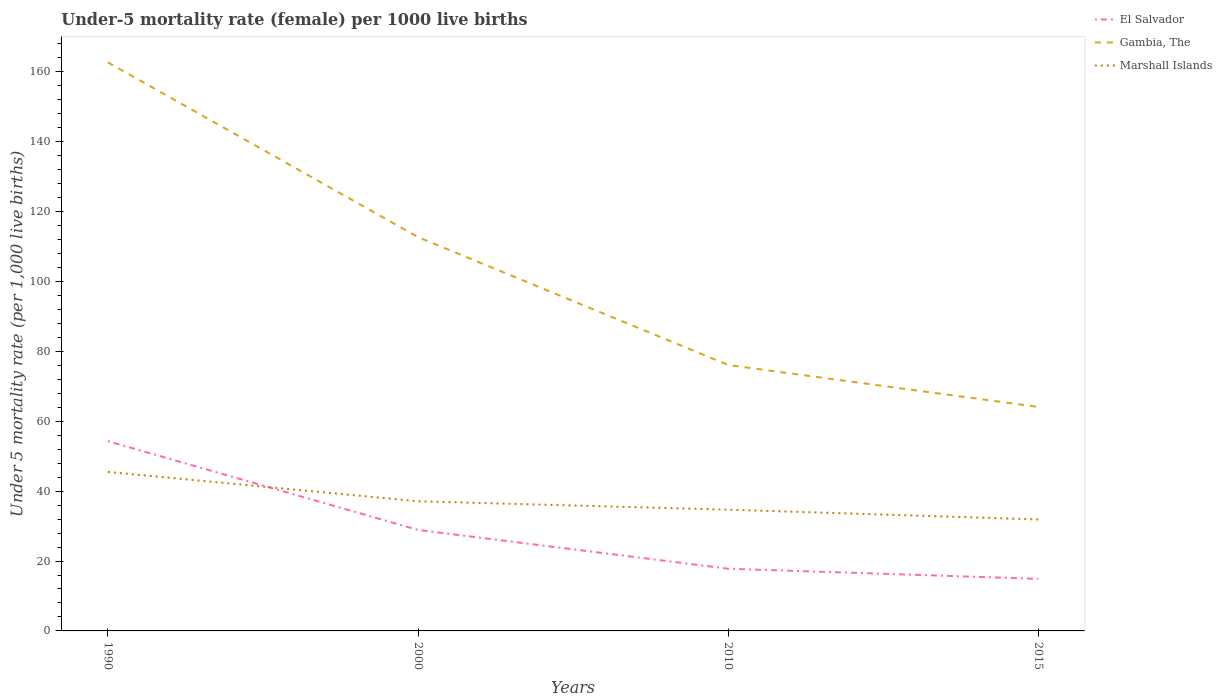How many different coloured lines are there?
Provide a short and direct response. 3. In which year was the under-five mortality rate in Gambia, The maximum?
Offer a very short reply. 2015. What is the total under-five mortality rate in Marshall Islands in the graph?
Give a very brief answer. 2.4. What is the difference between the highest and the second highest under-five mortality rate in Marshall Islands?
Your response must be concise. 13.6. What is the difference between the highest and the lowest under-five mortality rate in Gambia, The?
Offer a very short reply. 2. Are the values on the major ticks of Y-axis written in scientific E-notation?
Your response must be concise. No. Does the graph contain grids?
Provide a short and direct response. No. Where does the legend appear in the graph?
Offer a very short reply. Top right. What is the title of the graph?
Provide a short and direct response. Under-5 mortality rate (female) per 1000 live births. What is the label or title of the X-axis?
Offer a very short reply. Years. What is the label or title of the Y-axis?
Your response must be concise. Under 5 mortality rate (per 1,0 live births). What is the Under 5 mortality rate (per 1,000 live births) of El Salvador in 1990?
Give a very brief answer. 54.3. What is the Under 5 mortality rate (per 1,000 live births) of Gambia, The in 1990?
Offer a terse response. 162.7. What is the Under 5 mortality rate (per 1,000 live births) in Marshall Islands in 1990?
Make the answer very short. 45.5. What is the Under 5 mortality rate (per 1,000 live births) of El Salvador in 2000?
Ensure brevity in your answer.  28.9. What is the Under 5 mortality rate (per 1,000 live births) of Gambia, The in 2000?
Give a very brief answer. 112.7. What is the Under 5 mortality rate (per 1,000 live births) in Marshall Islands in 2000?
Make the answer very short. 37.1. What is the Under 5 mortality rate (per 1,000 live births) in Gambia, The in 2010?
Your response must be concise. 76.1. What is the Under 5 mortality rate (per 1,000 live births) of Marshall Islands in 2010?
Make the answer very short. 34.7. What is the Under 5 mortality rate (per 1,000 live births) of Gambia, The in 2015?
Offer a terse response. 64.1. What is the Under 5 mortality rate (per 1,000 live births) of Marshall Islands in 2015?
Keep it short and to the point. 31.9. Across all years, what is the maximum Under 5 mortality rate (per 1,000 live births) of El Salvador?
Give a very brief answer. 54.3. Across all years, what is the maximum Under 5 mortality rate (per 1,000 live births) in Gambia, The?
Keep it short and to the point. 162.7. Across all years, what is the maximum Under 5 mortality rate (per 1,000 live births) of Marshall Islands?
Provide a succinct answer. 45.5. Across all years, what is the minimum Under 5 mortality rate (per 1,000 live births) in El Salvador?
Your answer should be compact. 14.9. Across all years, what is the minimum Under 5 mortality rate (per 1,000 live births) of Gambia, The?
Your response must be concise. 64.1. Across all years, what is the minimum Under 5 mortality rate (per 1,000 live births) of Marshall Islands?
Your response must be concise. 31.9. What is the total Under 5 mortality rate (per 1,000 live births) in El Salvador in the graph?
Give a very brief answer. 115.9. What is the total Under 5 mortality rate (per 1,000 live births) in Gambia, The in the graph?
Offer a terse response. 415.6. What is the total Under 5 mortality rate (per 1,000 live births) of Marshall Islands in the graph?
Your answer should be compact. 149.2. What is the difference between the Under 5 mortality rate (per 1,000 live births) of El Salvador in 1990 and that in 2000?
Give a very brief answer. 25.4. What is the difference between the Under 5 mortality rate (per 1,000 live births) of Gambia, The in 1990 and that in 2000?
Ensure brevity in your answer.  50. What is the difference between the Under 5 mortality rate (per 1,000 live births) of El Salvador in 1990 and that in 2010?
Your answer should be very brief. 36.5. What is the difference between the Under 5 mortality rate (per 1,000 live births) in Gambia, The in 1990 and that in 2010?
Your answer should be very brief. 86.6. What is the difference between the Under 5 mortality rate (per 1,000 live births) of Marshall Islands in 1990 and that in 2010?
Ensure brevity in your answer.  10.8. What is the difference between the Under 5 mortality rate (per 1,000 live births) in El Salvador in 1990 and that in 2015?
Make the answer very short. 39.4. What is the difference between the Under 5 mortality rate (per 1,000 live births) of Gambia, The in 1990 and that in 2015?
Your response must be concise. 98.6. What is the difference between the Under 5 mortality rate (per 1,000 live births) in El Salvador in 2000 and that in 2010?
Your response must be concise. 11.1. What is the difference between the Under 5 mortality rate (per 1,000 live births) of Gambia, The in 2000 and that in 2010?
Keep it short and to the point. 36.6. What is the difference between the Under 5 mortality rate (per 1,000 live births) of El Salvador in 2000 and that in 2015?
Ensure brevity in your answer.  14. What is the difference between the Under 5 mortality rate (per 1,000 live births) in Gambia, The in 2000 and that in 2015?
Keep it short and to the point. 48.6. What is the difference between the Under 5 mortality rate (per 1,000 live births) of El Salvador in 2010 and that in 2015?
Provide a succinct answer. 2.9. What is the difference between the Under 5 mortality rate (per 1,000 live births) in El Salvador in 1990 and the Under 5 mortality rate (per 1,000 live births) in Gambia, The in 2000?
Offer a very short reply. -58.4. What is the difference between the Under 5 mortality rate (per 1,000 live births) of El Salvador in 1990 and the Under 5 mortality rate (per 1,000 live births) of Marshall Islands in 2000?
Offer a terse response. 17.2. What is the difference between the Under 5 mortality rate (per 1,000 live births) of Gambia, The in 1990 and the Under 5 mortality rate (per 1,000 live births) of Marshall Islands in 2000?
Offer a very short reply. 125.6. What is the difference between the Under 5 mortality rate (per 1,000 live births) of El Salvador in 1990 and the Under 5 mortality rate (per 1,000 live births) of Gambia, The in 2010?
Your answer should be compact. -21.8. What is the difference between the Under 5 mortality rate (per 1,000 live births) of El Salvador in 1990 and the Under 5 mortality rate (per 1,000 live births) of Marshall Islands in 2010?
Offer a terse response. 19.6. What is the difference between the Under 5 mortality rate (per 1,000 live births) in Gambia, The in 1990 and the Under 5 mortality rate (per 1,000 live births) in Marshall Islands in 2010?
Your answer should be very brief. 128. What is the difference between the Under 5 mortality rate (per 1,000 live births) in El Salvador in 1990 and the Under 5 mortality rate (per 1,000 live births) in Gambia, The in 2015?
Ensure brevity in your answer.  -9.8. What is the difference between the Under 5 mortality rate (per 1,000 live births) of El Salvador in 1990 and the Under 5 mortality rate (per 1,000 live births) of Marshall Islands in 2015?
Keep it short and to the point. 22.4. What is the difference between the Under 5 mortality rate (per 1,000 live births) in Gambia, The in 1990 and the Under 5 mortality rate (per 1,000 live births) in Marshall Islands in 2015?
Your answer should be very brief. 130.8. What is the difference between the Under 5 mortality rate (per 1,000 live births) of El Salvador in 2000 and the Under 5 mortality rate (per 1,000 live births) of Gambia, The in 2010?
Offer a very short reply. -47.2. What is the difference between the Under 5 mortality rate (per 1,000 live births) of Gambia, The in 2000 and the Under 5 mortality rate (per 1,000 live births) of Marshall Islands in 2010?
Provide a short and direct response. 78. What is the difference between the Under 5 mortality rate (per 1,000 live births) in El Salvador in 2000 and the Under 5 mortality rate (per 1,000 live births) in Gambia, The in 2015?
Offer a terse response. -35.2. What is the difference between the Under 5 mortality rate (per 1,000 live births) in Gambia, The in 2000 and the Under 5 mortality rate (per 1,000 live births) in Marshall Islands in 2015?
Keep it short and to the point. 80.8. What is the difference between the Under 5 mortality rate (per 1,000 live births) of El Salvador in 2010 and the Under 5 mortality rate (per 1,000 live births) of Gambia, The in 2015?
Give a very brief answer. -46.3. What is the difference between the Under 5 mortality rate (per 1,000 live births) of El Salvador in 2010 and the Under 5 mortality rate (per 1,000 live births) of Marshall Islands in 2015?
Your answer should be very brief. -14.1. What is the difference between the Under 5 mortality rate (per 1,000 live births) in Gambia, The in 2010 and the Under 5 mortality rate (per 1,000 live births) in Marshall Islands in 2015?
Provide a short and direct response. 44.2. What is the average Under 5 mortality rate (per 1,000 live births) of El Salvador per year?
Keep it short and to the point. 28.98. What is the average Under 5 mortality rate (per 1,000 live births) of Gambia, The per year?
Ensure brevity in your answer.  103.9. What is the average Under 5 mortality rate (per 1,000 live births) of Marshall Islands per year?
Your answer should be compact. 37.3. In the year 1990, what is the difference between the Under 5 mortality rate (per 1,000 live births) of El Salvador and Under 5 mortality rate (per 1,000 live births) of Gambia, The?
Make the answer very short. -108.4. In the year 1990, what is the difference between the Under 5 mortality rate (per 1,000 live births) of El Salvador and Under 5 mortality rate (per 1,000 live births) of Marshall Islands?
Keep it short and to the point. 8.8. In the year 1990, what is the difference between the Under 5 mortality rate (per 1,000 live births) in Gambia, The and Under 5 mortality rate (per 1,000 live births) in Marshall Islands?
Keep it short and to the point. 117.2. In the year 2000, what is the difference between the Under 5 mortality rate (per 1,000 live births) in El Salvador and Under 5 mortality rate (per 1,000 live births) in Gambia, The?
Your response must be concise. -83.8. In the year 2000, what is the difference between the Under 5 mortality rate (per 1,000 live births) of Gambia, The and Under 5 mortality rate (per 1,000 live births) of Marshall Islands?
Your answer should be very brief. 75.6. In the year 2010, what is the difference between the Under 5 mortality rate (per 1,000 live births) of El Salvador and Under 5 mortality rate (per 1,000 live births) of Gambia, The?
Your answer should be compact. -58.3. In the year 2010, what is the difference between the Under 5 mortality rate (per 1,000 live births) of El Salvador and Under 5 mortality rate (per 1,000 live births) of Marshall Islands?
Give a very brief answer. -16.9. In the year 2010, what is the difference between the Under 5 mortality rate (per 1,000 live births) of Gambia, The and Under 5 mortality rate (per 1,000 live births) of Marshall Islands?
Ensure brevity in your answer.  41.4. In the year 2015, what is the difference between the Under 5 mortality rate (per 1,000 live births) of El Salvador and Under 5 mortality rate (per 1,000 live births) of Gambia, The?
Offer a very short reply. -49.2. In the year 2015, what is the difference between the Under 5 mortality rate (per 1,000 live births) in Gambia, The and Under 5 mortality rate (per 1,000 live births) in Marshall Islands?
Your answer should be compact. 32.2. What is the ratio of the Under 5 mortality rate (per 1,000 live births) of El Salvador in 1990 to that in 2000?
Provide a succinct answer. 1.88. What is the ratio of the Under 5 mortality rate (per 1,000 live births) of Gambia, The in 1990 to that in 2000?
Ensure brevity in your answer.  1.44. What is the ratio of the Under 5 mortality rate (per 1,000 live births) of Marshall Islands in 1990 to that in 2000?
Provide a short and direct response. 1.23. What is the ratio of the Under 5 mortality rate (per 1,000 live births) of El Salvador in 1990 to that in 2010?
Your response must be concise. 3.05. What is the ratio of the Under 5 mortality rate (per 1,000 live births) in Gambia, The in 1990 to that in 2010?
Your answer should be very brief. 2.14. What is the ratio of the Under 5 mortality rate (per 1,000 live births) of Marshall Islands in 1990 to that in 2010?
Offer a very short reply. 1.31. What is the ratio of the Under 5 mortality rate (per 1,000 live births) of El Salvador in 1990 to that in 2015?
Provide a short and direct response. 3.64. What is the ratio of the Under 5 mortality rate (per 1,000 live births) in Gambia, The in 1990 to that in 2015?
Make the answer very short. 2.54. What is the ratio of the Under 5 mortality rate (per 1,000 live births) in Marshall Islands in 1990 to that in 2015?
Ensure brevity in your answer.  1.43. What is the ratio of the Under 5 mortality rate (per 1,000 live births) in El Salvador in 2000 to that in 2010?
Your answer should be compact. 1.62. What is the ratio of the Under 5 mortality rate (per 1,000 live births) in Gambia, The in 2000 to that in 2010?
Offer a very short reply. 1.48. What is the ratio of the Under 5 mortality rate (per 1,000 live births) in Marshall Islands in 2000 to that in 2010?
Offer a very short reply. 1.07. What is the ratio of the Under 5 mortality rate (per 1,000 live births) in El Salvador in 2000 to that in 2015?
Offer a very short reply. 1.94. What is the ratio of the Under 5 mortality rate (per 1,000 live births) in Gambia, The in 2000 to that in 2015?
Make the answer very short. 1.76. What is the ratio of the Under 5 mortality rate (per 1,000 live births) of Marshall Islands in 2000 to that in 2015?
Provide a short and direct response. 1.16. What is the ratio of the Under 5 mortality rate (per 1,000 live births) of El Salvador in 2010 to that in 2015?
Your answer should be compact. 1.19. What is the ratio of the Under 5 mortality rate (per 1,000 live births) of Gambia, The in 2010 to that in 2015?
Make the answer very short. 1.19. What is the ratio of the Under 5 mortality rate (per 1,000 live births) in Marshall Islands in 2010 to that in 2015?
Give a very brief answer. 1.09. What is the difference between the highest and the second highest Under 5 mortality rate (per 1,000 live births) in El Salvador?
Your answer should be very brief. 25.4. What is the difference between the highest and the second highest Under 5 mortality rate (per 1,000 live births) of Marshall Islands?
Your answer should be very brief. 8.4. What is the difference between the highest and the lowest Under 5 mortality rate (per 1,000 live births) of El Salvador?
Make the answer very short. 39.4. What is the difference between the highest and the lowest Under 5 mortality rate (per 1,000 live births) in Gambia, The?
Give a very brief answer. 98.6. What is the difference between the highest and the lowest Under 5 mortality rate (per 1,000 live births) in Marshall Islands?
Ensure brevity in your answer.  13.6. 